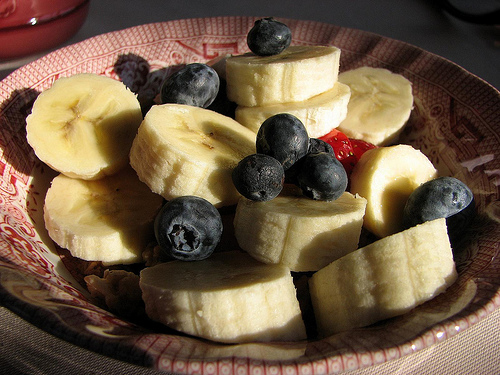<image>
Is the blueberry on the banana? Yes. Looking at the image, I can see the blueberry is positioned on top of the banana, with the banana providing support. 